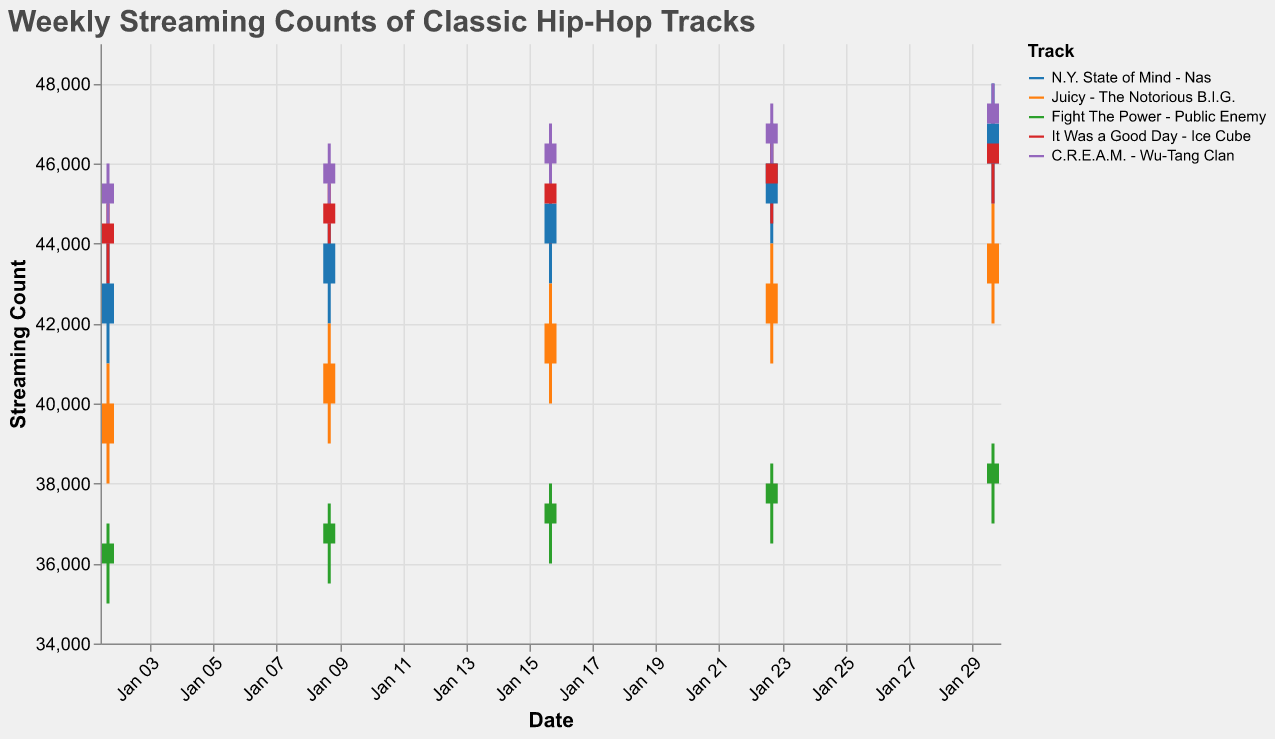What is the title of the plot? The title is the text displayed at the top of the plot, indicating what the data represents. Here, the title is provided in the plot specification.
Answer: Weekly Streaming Counts of Classic Hip-Hop Tracks Which track has the highest high streaming count on January 30, 2023? To find this, look for the highest "High" value for January 30, 2023, and identify the associated track. "C.R.E.A.M." by Wu-Tang Clan has a high value of 48000.
Answer: C.R.E.A.M. - Wu-Tang Clan What are the axis labels in the plot? The labels for the axes are given in the plot specification under the "title" attribute for each axis. The x-axis is labeled "Date" and the y-axis is labeled "Streaming Count".
Answer: Date and Streaming Count Between "Juicy" by The Notorious B.I.G. and "Fight The Power" by Public Enemy, which track had a higher close value on January 16, 2023? Compare the close values of both tracks for January 16, 2023. "Juicy" had a close value of 42000, while "Fight The Power" had 37500.
Answer: Juicy - The Notorious B.I.G How did the streaming count of "N.Y. State of Mind" by Nas change from January 2 to January 30, 2023? Observe the open values for January 2 and the close values for January 30 for "N.Y. State of Mind". The streaming count opened at 42000 on January 2 and closed at 47000 on January 30. The change is 47000 - 42000 = 5000.
Answer: Increased by 5000 What was the average high streaming count for "Fight The Power" by Public Enemy across all given dates? Add the high values for each date and divide by the number of dates: (37000 + 37500 + 38000 + 38500) / 4. Calculation: (37000 + 37500 + 38000 + 38500) = 151000; 151000 / 4 = 37750.
Answer: 37750 Which track had the most significant increase in streaming count between the open and close values on January 9, 2023? Calculate the difference between the open and close values for each track on January 9 and compare them. "It Was a Good Day" by Ice Cube increased by 500 (44500 to 45000). Calculation: 45000 - 44500 = 500.
Answer: It Was a Good Day - Ice Cube On which date did "C.R.E.A.M." by Wu-Tang Clan achieve its highest close value, and what was the value? Look through the close values for "C.R.E.A.M." across all dates and find the maximum. The highest close value was 47500 on January 30, 2023.
Answer: January 30, 2023, 47500 Which track had the lowest open value on January 2, 2023? Look at the open values for each track on January 2, 2023, and identify the smallest number. "Fight The Power" by Public Enemy had an open value of 36000, which is the lowest.
Answer: Fight The Power - Public Enemy How many tracks are represented in the plot? Identify the unique track names given in the "color" field under encoding in the plot specification. There are 5 tracks.
Answer: 5 